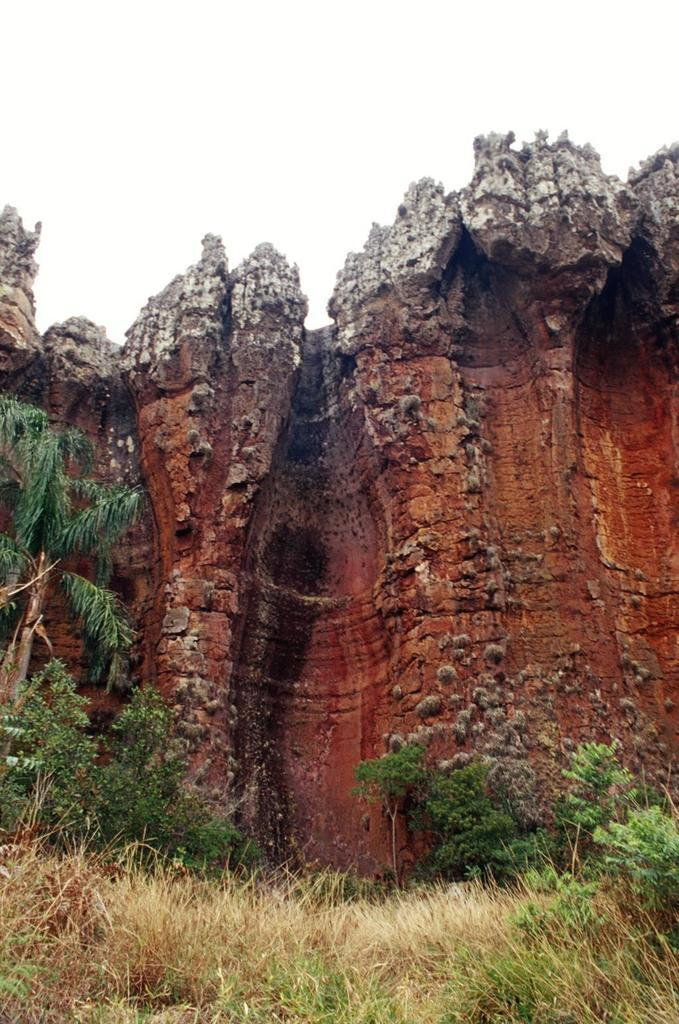What type of vegetation is visible in the image? There is grass, a plant, and a tree visible in the image. Can you describe the plant in the image? Unfortunately, the facts provided do not give any specific details about the plant in the image. What is the largest vegetation element in the image? The tree is the largest vegetation element in the image. How many chickens are sitting on the tree in the image? There are no chickens present in the image; it features grass, a plant, and a tree. What type of muscle is visible in the image? The image does not depict any muscles, as it features only vegetation elements such as grass, a plant, and a tree. 